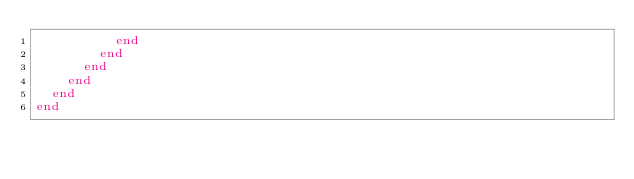<code> <loc_0><loc_0><loc_500><loc_500><_Ruby_>          end
        end
      end
    end
  end
end
</code> 